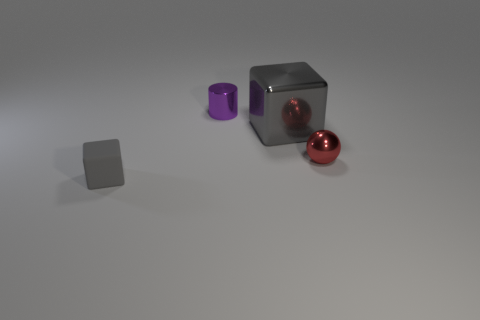Subtract 1 cubes. How many cubes are left? 1 Subtract 1 purple cylinders. How many objects are left? 3 Subtract all cylinders. How many objects are left? 3 Subtract all brown cylinders. Subtract all cyan blocks. How many cylinders are left? 1 Subtract all green spheres. How many red cylinders are left? 0 Subtract all cubes. Subtract all small red objects. How many objects are left? 1 Add 4 small red shiny balls. How many small red shiny balls are left? 5 Add 4 spheres. How many spheres exist? 5 Add 4 small gray blocks. How many objects exist? 8 